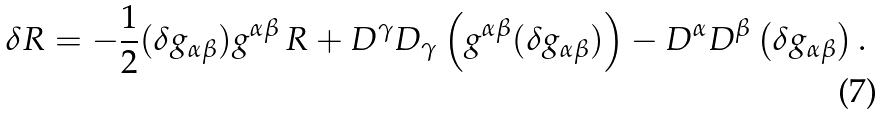Convert formula to latex. <formula><loc_0><loc_0><loc_500><loc_500>\delta R = - \frac { 1 } { 2 } ( \delta g _ { \alpha \beta } ) g ^ { \alpha \beta } \, R + D ^ { \gamma } D _ { \gamma } \left ( g ^ { \alpha \beta } ( \delta g _ { \alpha \beta } ) \right ) - D ^ { \alpha } D ^ { \beta } \left ( \delta g _ { \alpha \beta } \right ) .</formula> 